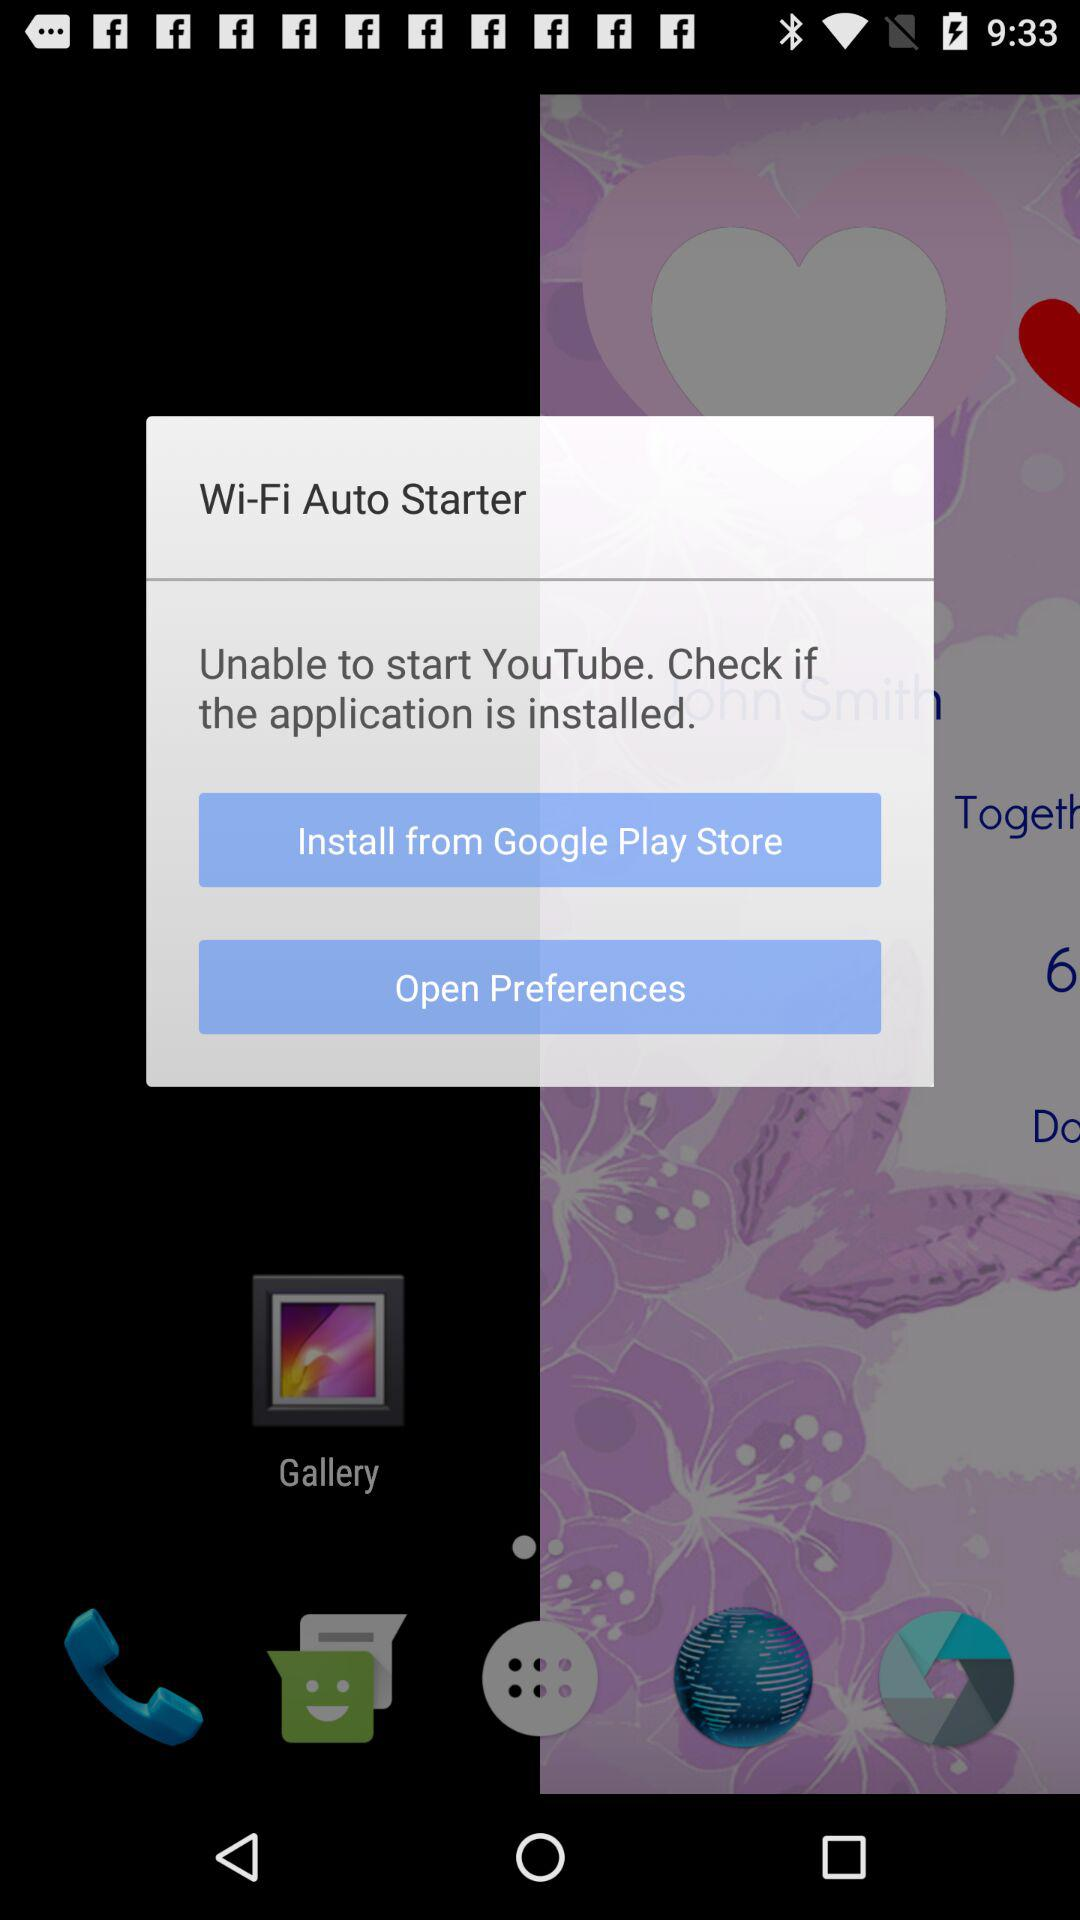How many actions are available to fix the YouTube issue?
Answer the question using a single word or phrase. 2 